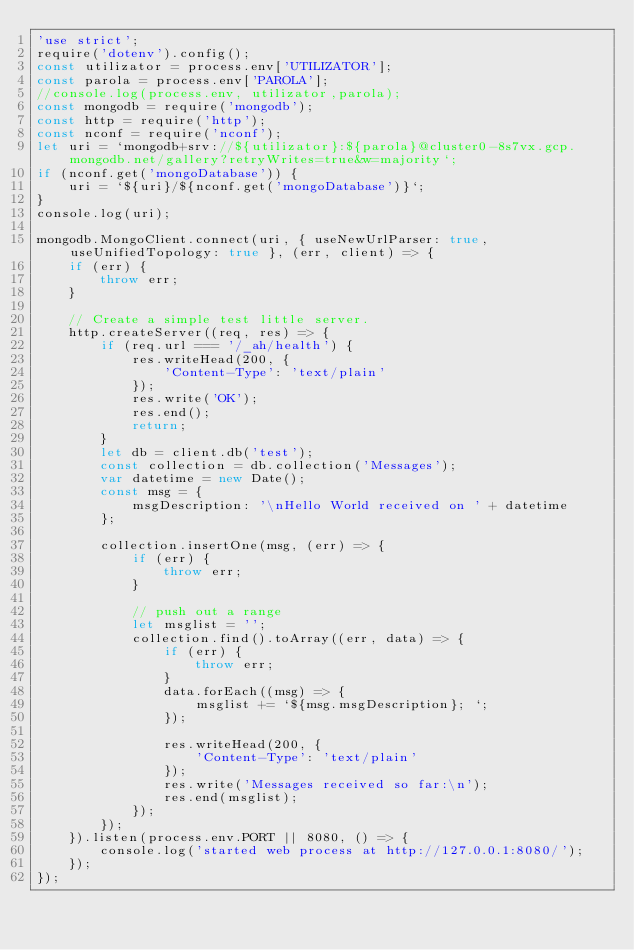Convert code to text. <code><loc_0><loc_0><loc_500><loc_500><_JavaScript_>'use strict';
require('dotenv').config();
const utilizator = process.env['UTILIZATOR'];
const parola = process.env['PAROLA'];
//console.log(process.env, utilizator,parola);
const mongodb = require('mongodb');
const http = require('http');
const nconf = require('nconf');
let uri = `mongodb+srv://${utilizator}:${parola}@cluster0-8s7vx.gcp.mongodb.net/gallery?retryWrites=true&w=majority`;
if (nconf.get('mongoDatabase')) {
    uri = `${uri}/${nconf.get('mongoDatabase')}`;
}
console.log(uri);

mongodb.MongoClient.connect(uri, { useNewUrlParser: true, useUnifiedTopology: true }, (err, client) => {
    if (err) {
        throw err;
    }

    // Create a simple test little server.
    http.createServer((req, res) => {
        if (req.url === '/_ah/health') {
            res.writeHead(200, {
                'Content-Type': 'text/plain'
            });
            res.write('OK');
            res.end();
            return;
        }
        let db = client.db('test');
        const collection = db.collection('Messages');
        var datetime = new Date();
        const msg = {
            msgDescription: '\nHello World received on ' + datetime
        };

        collection.insertOne(msg, (err) => {
            if (err) {
                throw err;
            }

            // push out a range
            let msglist = '';
            collection.find().toArray((err, data) => {
                if (err) {
                    throw err;
                }
                data.forEach((msg) => {
                    msglist += `${msg.msgDescription}; `;
                });

                res.writeHead(200, {
                    'Content-Type': 'text/plain'
                });
                res.write('Messages received so far:\n');
                res.end(msglist);
            });
        });
    }).listen(process.env.PORT || 8080, () => {
        console.log('started web process at http://127.0.0.1:8080/');
    });
});</code> 